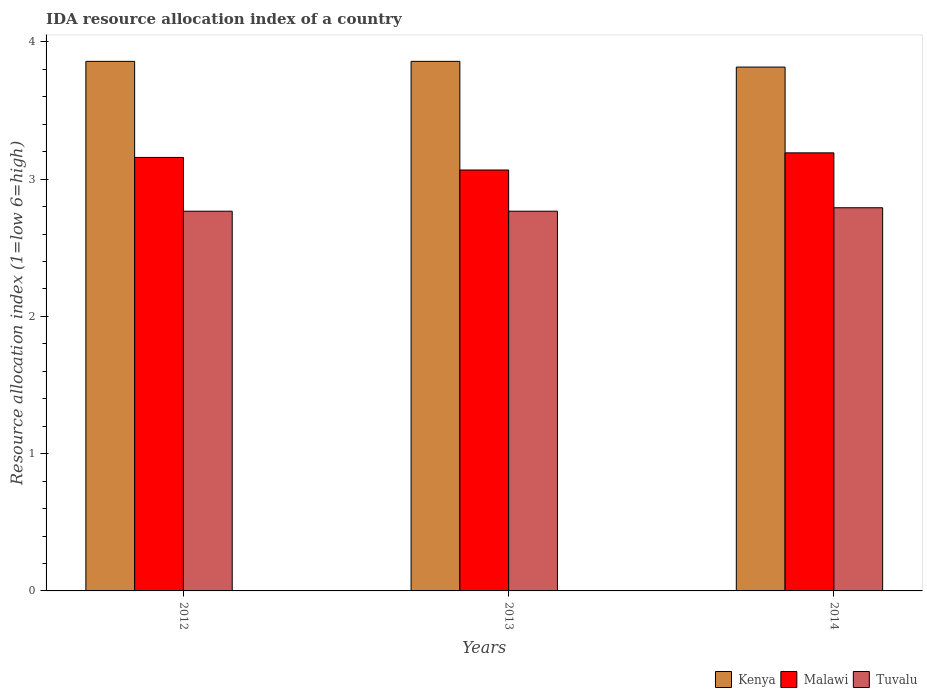How many groups of bars are there?
Provide a short and direct response. 3. Are the number of bars per tick equal to the number of legend labels?
Keep it short and to the point. Yes. How many bars are there on the 1st tick from the left?
Make the answer very short. 3. What is the label of the 3rd group of bars from the left?
Offer a terse response. 2014. What is the IDA resource allocation index in Kenya in 2014?
Offer a very short reply. 3.82. Across all years, what is the maximum IDA resource allocation index in Kenya?
Give a very brief answer. 3.86. Across all years, what is the minimum IDA resource allocation index in Malawi?
Keep it short and to the point. 3.07. In which year was the IDA resource allocation index in Tuvalu maximum?
Give a very brief answer. 2014. In which year was the IDA resource allocation index in Tuvalu minimum?
Offer a terse response. 2012. What is the total IDA resource allocation index in Kenya in the graph?
Offer a very short reply. 11.53. What is the difference between the IDA resource allocation index in Tuvalu in 2013 and that in 2014?
Keep it short and to the point. -0.03. What is the difference between the IDA resource allocation index in Kenya in 2014 and the IDA resource allocation index in Malawi in 2013?
Provide a short and direct response. 0.75. What is the average IDA resource allocation index in Malawi per year?
Your answer should be compact. 3.14. In the year 2014, what is the difference between the IDA resource allocation index in Tuvalu and IDA resource allocation index in Malawi?
Give a very brief answer. -0.4. In how many years, is the IDA resource allocation index in Malawi greater than 0.6000000000000001?
Keep it short and to the point. 3. What is the ratio of the IDA resource allocation index in Tuvalu in 2012 to that in 2014?
Your answer should be very brief. 0.99. What is the difference between the highest and the second highest IDA resource allocation index in Malawi?
Give a very brief answer. 0.03. What is the difference between the highest and the lowest IDA resource allocation index in Tuvalu?
Provide a succinct answer. 0.03. In how many years, is the IDA resource allocation index in Tuvalu greater than the average IDA resource allocation index in Tuvalu taken over all years?
Your answer should be compact. 1. What does the 3rd bar from the left in 2013 represents?
Give a very brief answer. Tuvalu. What does the 3rd bar from the right in 2013 represents?
Provide a short and direct response. Kenya. How many bars are there?
Your answer should be compact. 9. What is the difference between two consecutive major ticks on the Y-axis?
Make the answer very short. 1. Does the graph contain any zero values?
Ensure brevity in your answer.  No. Does the graph contain grids?
Provide a short and direct response. No. Where does the legend appear in the graph?
Ensure brevity in your answer.  Bottom right. How are the legend labels stacked?
Your answer should be compact. Horizontal. What is the title of the graph?
Keep it short and to the point. IDA resource allocation index of a country. Does "Botswana" appear as one of the legend labels in the graph?
Provide a short and direct response. No. What is the label or title of the Y-axis?
Your answer should be very brief. Resource allocation index (1=low 6=high). What is the Resource allocation index (1=low 6=high) in Kenya in 2012?
Ensure brevity in your answer.  3.86. What is the Resource allocation index (1=low 6=high) of Malawi in 2012?
Make the answer very short. 3.16. What is the Resource allocation index (1=low 6=high) of Tuvalu in 2012?
Your answer should be very brief. 2.77. What is the Resource allocation index (1=low 6=high) in Kenya in 2013?
Make the answer very short. 3.86. What is the Resource allocation index (1=low 6=high) of Malawi in 2013?
Keep it short and to the point. 3.07. What is the Resource allocation index (1=low 6=high) of Tuvalu in 2013?
Make the answer very short. 2.77. What is the Resource allocation index (1=low 6=high) in Kenya in 2014?
Ensure brevity in your answer.  3.82. What is the Resource allocation index (1=low 6=high) of Malawi in 2014?
Your answer should be compact. 3.19. What is the Resource allocation index (1=low 6=high) of Tuvalu in 2014?
Ensure brevity in your answer.  2.79. Across all years, what is the maximum Resource allocation index (1=low 6=high) in Kenya?
Your response must be concise. 3.86. Across all years, what is the maximum Resource allocation index (1=low 6=high) of Malawi?
Make the answer very short. 3.19. Across all years, what is the maximum Resource allocation index (1=low 6=high) of Tuvalu?
Your answer should be very brief. 2.79. Across all years, what is the minimum Resource allocation index (1=low 6=high) of Kenya?
Ensure brevity in your answer.  3.82. Across all years, what is the minimum Resource allocation index (1=low 6=high) in Malawi?
Your answer should be compact. 3.07. Across all years, what is the minimum Resource allocation index (1=low 6=high) of Tuvalu?
Give a very brief answer. 2.77. What is the total Resource allocation index (1=low 6=high) in Kenya in the graph?
Give a very brief answer. 11.53. What is the total Resource allocation index (1=low 6=high) of Malawi in the graph?
Ensure brevity in your answer.  9.42. What is the total Resource allocation index (1=low 6=high) of Tuvalu in the graph?
Offer a very short reply. 8.32. What is the difference between the Resource allocation index (1=low 6=high) in Malawi in 2012 and that in 2013?
Provide a succinct answer. 0.09. What is the difference between the Resource allocation index (1=low 6=high) in Tuvalu in 2012 and that in 2013?
Give a very brief answer. 0. What is the difference between the Resource allocation index (1=low 6=high) of Kenya in 2012 and that in 2014?
Offer a very short reply. 0.04. What is the difference between the Resource allocation index (1=low 6=high) of Malawi in 2012 and that in 2014?
Your answer should be compact. -0.03. What is the difference between the Resource allocation index (1=low 6=high) in Tuvalu in 2012 and that in 2014?
Offer a terse response. -0.03. What is the difference between the Resource allocation index (1=low 6=high) of Kenya in 2013 and that in 2014?
Provide a short and direct response. 0.04. What is the difference between the Resource allocation index (1=low 6=high) of Malawi in 2013 and that in 2014?
Provide a succinct answer. -0.12. What is the difference between the Resource allocation index (1=low 6=high) in Tuvalu in 2013 and that in 2014?
Provide a short and direct response. -0.03. What is the difference between the Resource allocation index (1=low 6=high) of Kenya in 2012 and the Resource allocation index (1=low 6=high) of Malawi in 2013?
Offer a terse response. 0.79. What is the difference between the Resource allocation index (1=low 6=high) in Kenya in 2012 and the Resource allocation index (1=low 6=high) in Tuvalu in 2013?
Your response must be concise. 1.09. What is the difference between the Resource allocation index (1=low 6=high) in Malawi in 2012 and the Resource allocation index (1=low 6=high) in Tuvalu in 2013?
Your response must be concise. 0.39. What is the difference between the Resource allocation index (1=low 6=high) of Kenya in 2012 and the Resource allocation index (1=low 6=high) of Tuvalu in 2014?
Your response must be concise. 1.07. What is the difference between the Resource allocation index (1=low 6=high) in Malawi in 2012 and the Resource allocation index (1=low 6=high) in Tuvalu in 2014?
Provide a succinct answer. 0.37. What is the difference between the Resource allocation index (1=low 6=high) of Kenya in 2013 and the Resource allocation index (1=low 6=high) of Tuvalu in 2014?
Give a very brief answer. 1.07. What is the difference between the Resource allocation index (1=low 6=high) of Malawi in 2013 and the Resource allocation index (1=low 6=high) of Tuvalu in 2014?
Provide a succinct answer. 0.28. What is the average Resource allocation index (1=low 6=high) in Kenya per year?
Your answer should be very brief. 3.84. What is the average Resource allocation index (1=low 6=high) in Malawi per year?
Provide a succinct answer. 3.14. What is the average Resource allocation index (1=low 6=high) in Tuvalu per year?
Your response must be concise. 2.77. In the year 2012, what is the difference between the Resource allocation index (1=low 6=high) in Kenya and Resource allocation index (1=low 6=high) in Tuvalu?
Ensure brevity in your answer.  1.09. In the year 2012, what is the difference between the Resource allocation index (1=low 6=high) of Malawi and Resource allocation index (1=low 6=high) of Tuvalu?
Provide a short and direct response. 0.39. In the year 2013, what is the difference between the Resource allocation index (1=low 6=high) of Kenya and Resource allocation index (1=low 6=high) of Malawi?
Offer a terse response. 0.79. In the year 2013, what is the difference between the Resource allocation index (1=low 6=high) of Kenya and Resource allocation index (1=low 6=high) of Tuvalu?
Your response must be concise. 1.09. In the year 2013, what is the difference between the Resource allocation index (1=low 6=high) of Malawi and Resource allocation index (1=low 6=high) of Tuvalu?
Ensure brevity in your answer.  0.3. In the year 2014, what is the difference between the Resource allocation index (1=low 6=high) in Kenya and Resource allocation index (1=low 6=high) in Malawi?
Your response must be concise. 0.62. In the year 2014, what is the difference between the Resource allocation index (1=low 6=high) in Kenya and Resource allocation index (1=low 6=high) in Tuvalu?
Offer a terse response. 1.02. In the year 2014, what is the difference between the Resource allocation index (1=low 6=high) in Malawi and Resource allocation index (1=low 6=high) in Tuvalu?
Your answer should be very brief. 0.4. What is the ratio of the Resource allocation index (1=low 6=high) in Kenya in 2012 to that in 2013?
Provide a short and direct response. 1. What is the ratio of the Resource allocation index (1=low 6=high) of Malawi in 2012 to that in 2013?
Give a very brief answer. 1.03. What is the ratio of the Resource allocation index (1=low 6=high) of Tuvalu in 2012 to that in 2013?
Make the answer very short. 1. What is the ratio of the Resource allocation index (1=low 6=high) of Kenya in 2012 to that in 2014?
Your answer should be very brief. 1.01. What is the ratio of the Resource allocation index (1=low 6=high) in Kenya in 2013 to that in 2014?
Offer a terse response. 1.01. What is the ratio of the Resource allocation index (1=low 6=high) of Malawi in 2013 to that in 2014?
Your answer should be very brief. 0.96. What is the difference between the highest and the second highest Resource allocation index (1=low 6=high) in Kenya?
Provide a short and direct response. 0. What is the difference between the highest and the second highest Resource allocation index (1=low 6=high) in Tuvalu?
Your answer should be very brief. 0.03. What is the difference between the highest and the lowest Resource allocation index (1=low 6=high) of Kenya?
Your answer should be very brief. 0.04. What is the difference between the highest and the lowest Resource allocation index (1=low 6=high) of Malawi?
Keep it short and to the point. 0.12. What is the difference between the highest and the lowest Resource allocation index (1=low 6=high) of Tuvalu?
Ensure brevity in your answer.  0.03. 